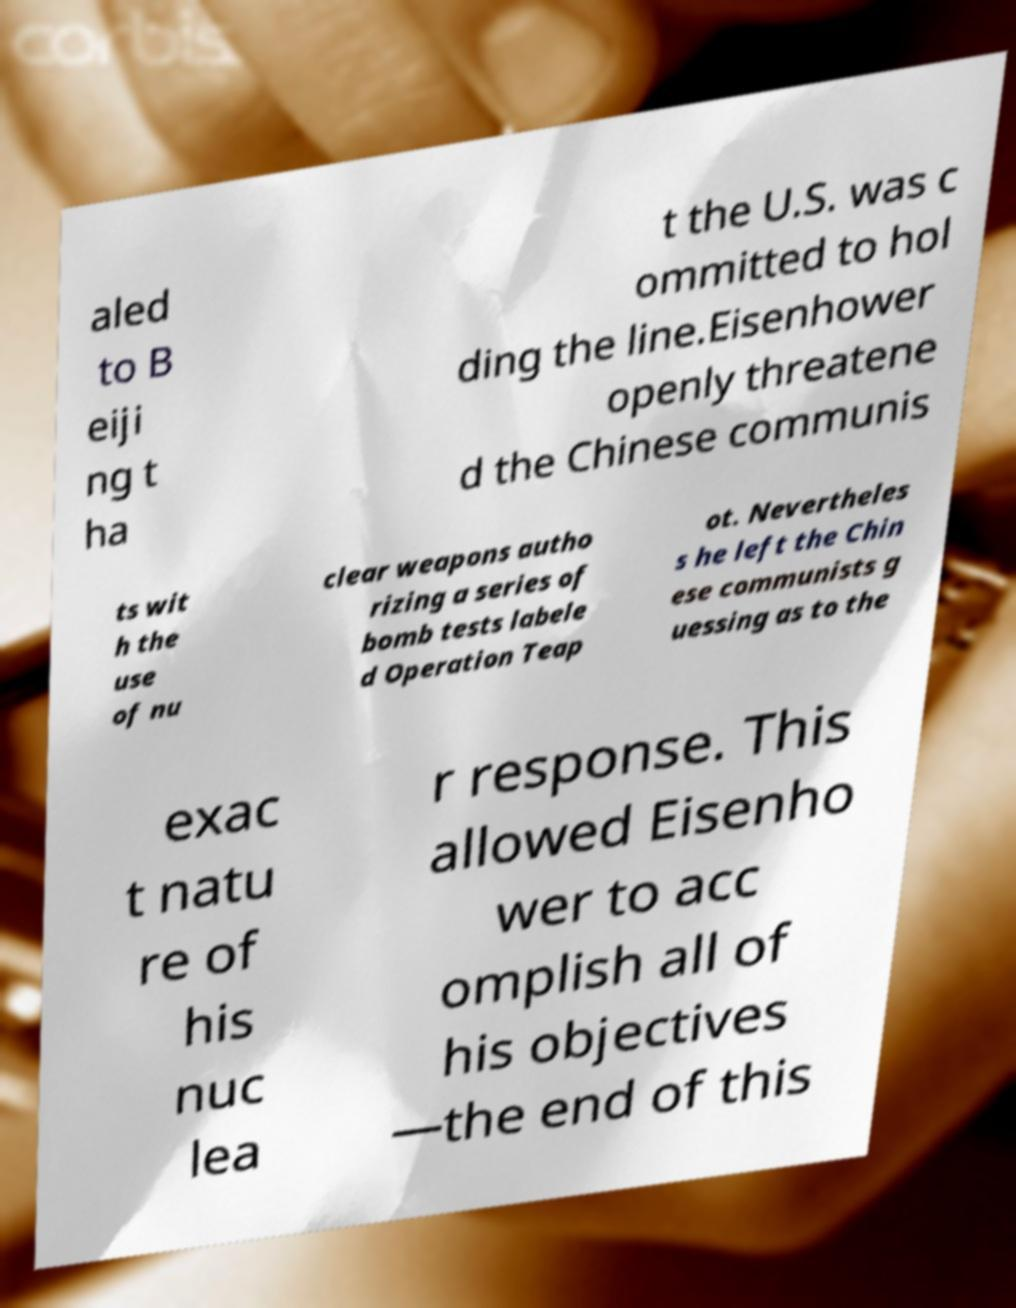What messages or text are displayed in this image? I need them in a readable, typed format. aled to B eiji ng t ha t the U.S. was c ommitted to hol ding the line.Eisenhower openly threatene d the Chinese communis ts wit h the use of nu clear weapons autho rizing a series of bomb tests labele d Operation Teap ot. Nevertheles s he left the Chin ese communists g uessing as to the exac t natu re of his nuc lea r response. This allowed Eisenho wer to acc omplish all of his objectives —the end of this 